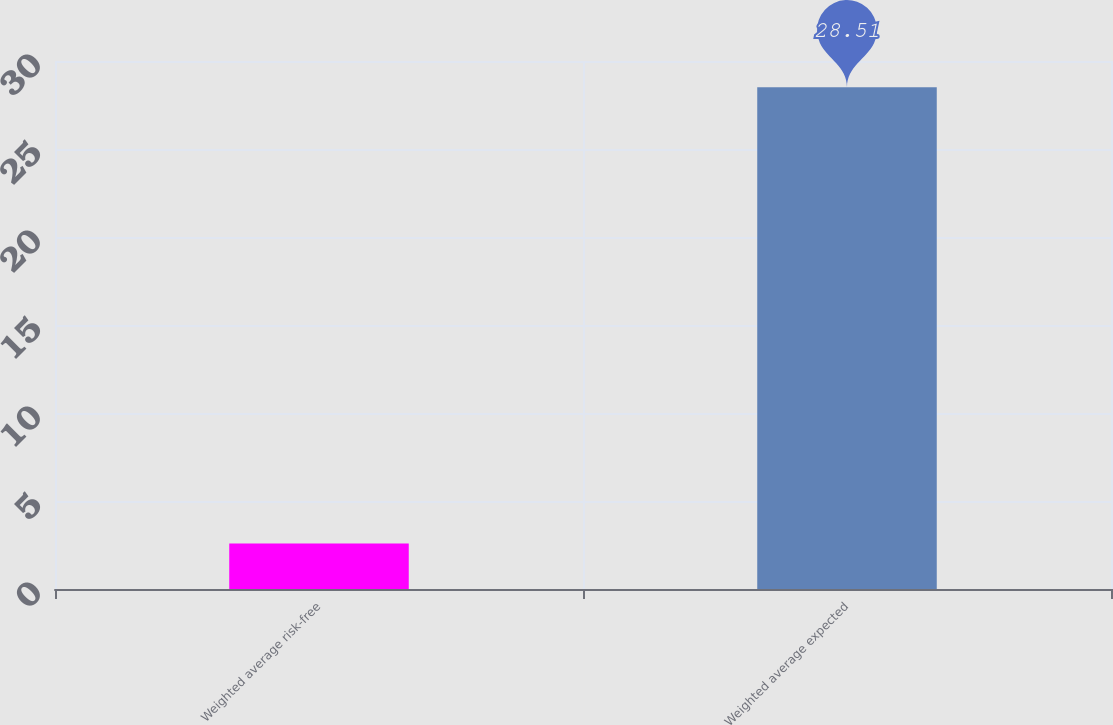<chart> <loc_0><loc_0><loc_500><loc_500><bar_chart><fcel>Weighted average risk-free<fcel>Weighted average expected<nl><fcel>2.58<fcel>28.51<nl></chart> 